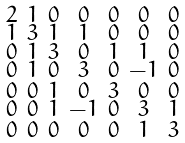Convert formula to latex. <formula><loc_0><loc_0><loc_500><loc_500>\begin{smallmatrix} 2 & 1 & 0 & 0 & 0 & 0 & 0 \\ 1 & 3 & 1 & 1 & 0 & 0 & 0 \\ 0 & 1 & 3 & 0 & 1 & 1 & 0 \\ 0 & 1 & 0 & 3 & 0 & - 1 & 0 \\ 0 & 0 & 1 & 0 & 3 & 0 & 0 \\ 0 & 0 & 1 & - 1 & 0 & 3 & 1 \\ 0 & 0 & 0 & 0 & 0 & 1 & 3 \end{smallmatrix}</formula> 